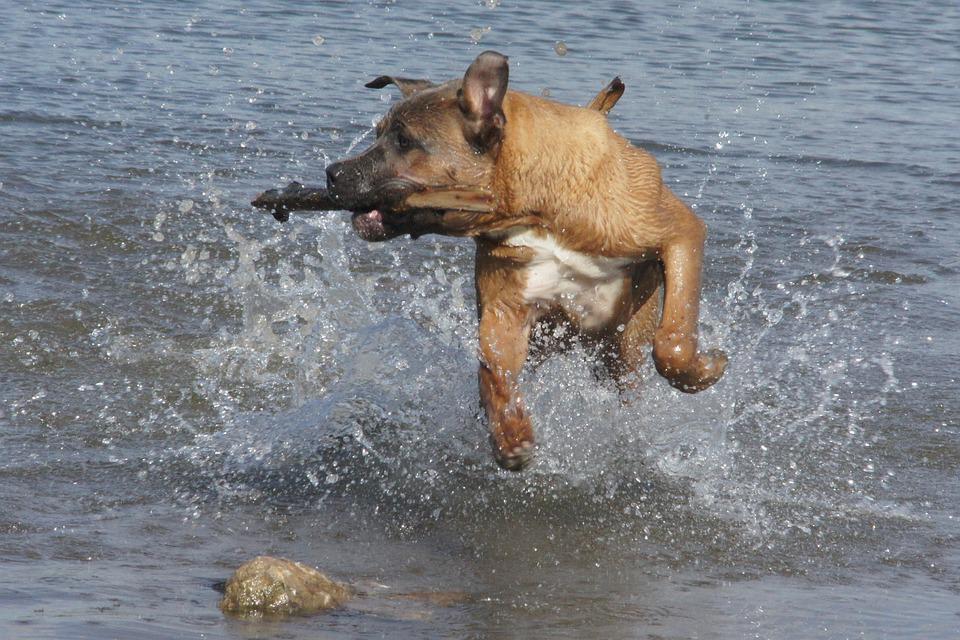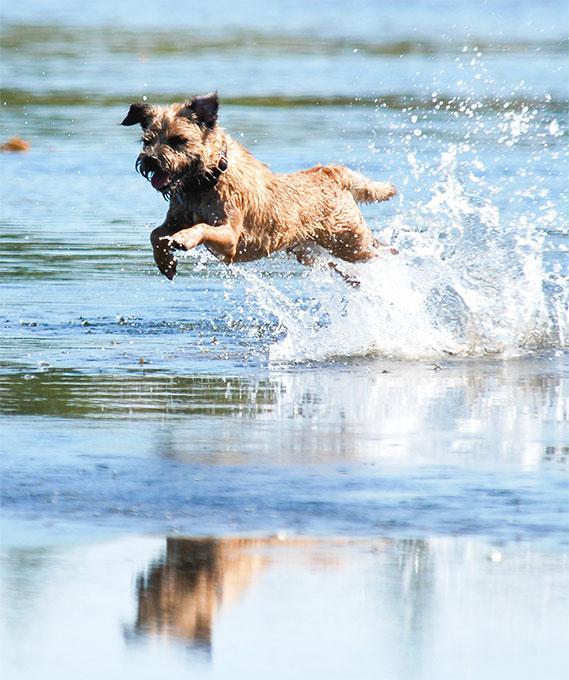The first image is the image on the left, the second image is the image on the right. For the images displayed, is the sentence "Each image contains a wet dog in mid stride over water." factually correct? Answer yes or no. Yes. The first image is the image on the left, the second image is the image on the right. Considering the images on both sides, is "dogs are leaping in the water" valid? Answer yes or no. Yes. 